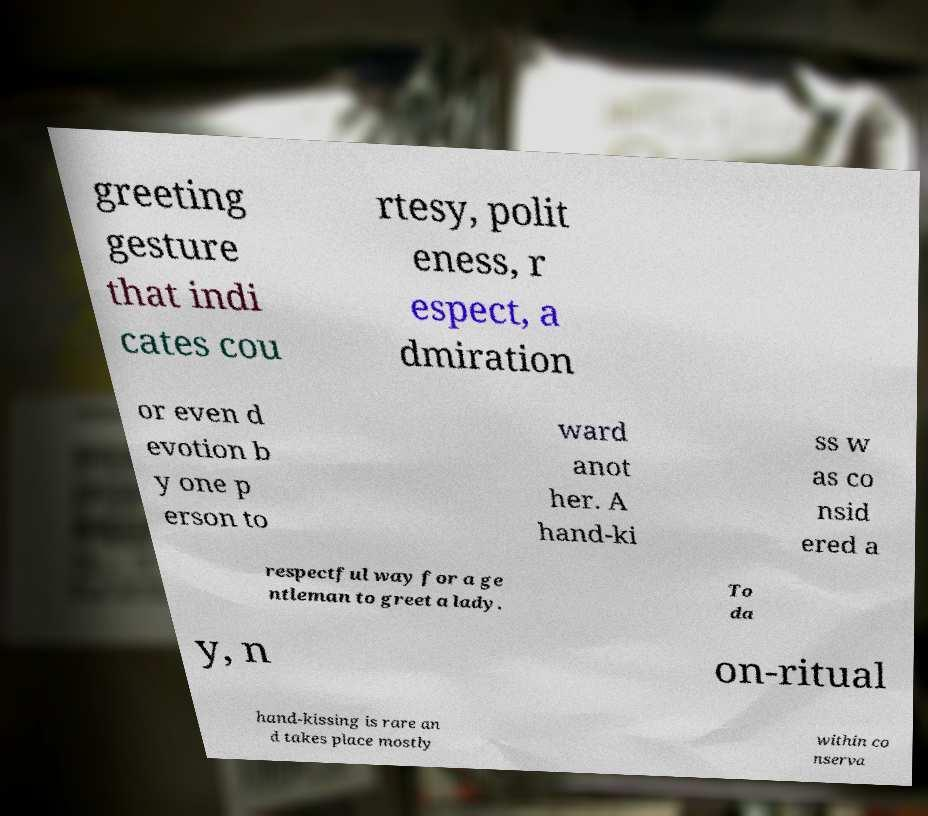What messages or text are displayed in this image? I need them in a readable, typed format. greeting gesture that indi cates cou rtesy, polit eness, r espect, a dmiration or even d evotion b y one p erson to ward anot her. A hand-ki ss w as co nsid ered a respectful way for a ge ntleman to greet a lady. To da y, n on-ritual hand-kissing is rare an d takes place mostly within co nserva 